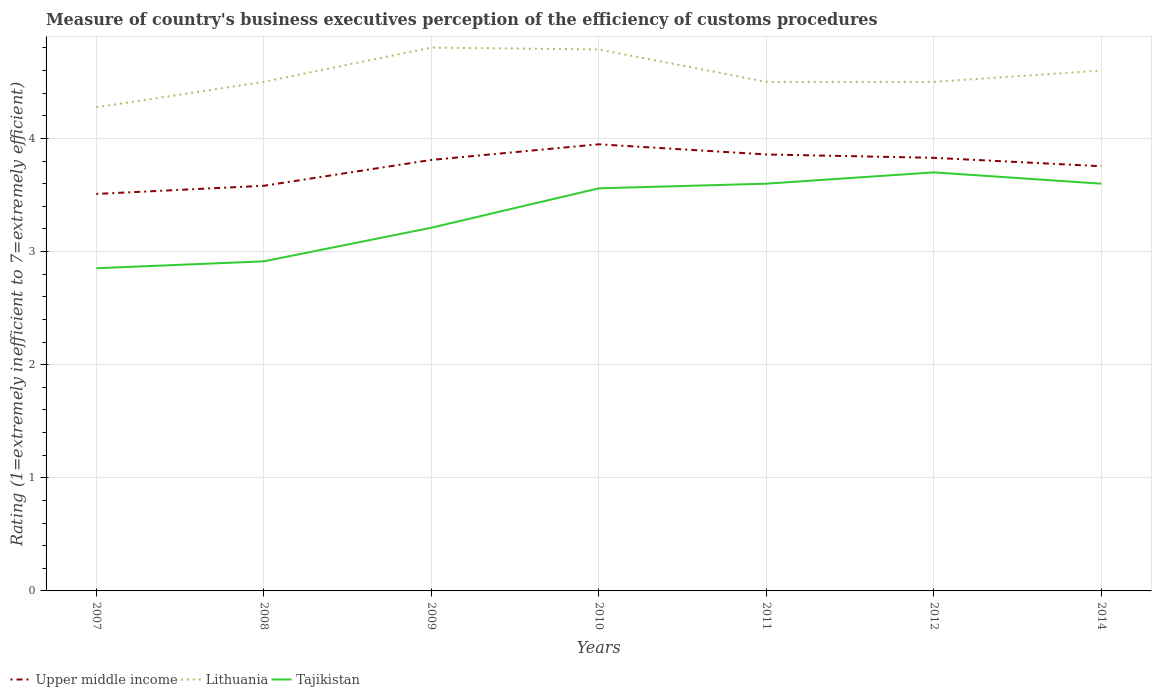How many different coloured lines are there?
Provide a succinct answer. 3. Is the number of lines equal to the number of legend labels?
Provide a succinct answer. Yes. Across all years, what is the maximum rating of the efficiency of customs procedure in Tajikistan?
Your answer should be compact. 2.85. What is the total rating of the efficiency of customs procedure in Upper middle income in the graph?
Keep it short and to the point. -0.07. What is the difference between the highest and the second highest rating of the efficiency of customs procedure in Tajikistan?
Give a very brief answer. 0.85. How many lines are there?
Ensure brevity in your answer.  3. How many years are there in the graph?
Your answer should be very brief. 7. Are the values on the major ticks of Y-axis written in scientific E-notation?
Keep it short and to the point. No. Does the graph contain any zero values?
Make the answer very short. No. Does the graph contain grids?
Ensure brevity in your answer.  Yes. Where does the legend appear in the graph?
Provide a short and direct response. Bottom left. What is the title of the graph?
Your answer should be very brief. Measure of country's business executives perception of the efficiency of customs procedures. Does "Panama" appear as one of the legend labels in the graph?
Offer a very short reply. No. What is the label or title of the Y-axis?
Offer a terse response. Rating (1=extremely inefficient to 7=extremely efficient). What is the Rating (1=extremely inefficient to 7=extremely efficient) of Upper middle income in 2007?
Ensure brevity in your answer.  3.51. What is the Rating (1=extremely inefficient to 7=extremely efficient) of Lithuania in 2007?
Offer a very short reply. 4.28. What is the Rating (1=extremely inefficient to 7=extremely efficient) of Tajikistan in 2007?
Keep it short and to the point. 2.85. What is the Rating (1=extremely inefficient to 7=extremely efficient) of Upper middle income in 2008?
Your response must be concise. 3.58. What is the Rating (1=extremely inefficient to 7=extremely efficient) of Lithuania in 2008?
Provide a succinct answer. 4.5. What is the Rating (1=extremely inefficient to 7=extremely efficient) of Tajikistan in 2008?
Provide a succinct answer. 2.91. What is the Rating (1=extremely inefficient to 7=extremely efficient) in Upper middle income in 2009?
Give a very brief answer. 3.81. What is the Rating (1=extremely inefficient to 7=extremely efficient) of Lithuania in 2009?
Keep it short and to the point. 4.8. What is the Rating (1=extremely inefficient to 7=extremely efficient) in Tajikistan in 2009?
Ensure brevity in your answer.  3.21. What is the Rating (1=extremely inefficient to 7=extremely efficient) in Upper middle income in 2010?
Provide a short and direct response. 3.95. What is the Rating (1=extremely inefficient to 7=extremely efficient) in Lithuania in 2010?
Offer a terse response. 4.79. What is the Rating (1=extremely inefficient to 7=extremely efficient) of Tajikistan in 2010?
Your answer should be compact. 3.56. What is the Rating (1=extremely inefficient to 7=extremely efficient) in Upper middle income in 2011?
Your answer should be compact. 3.86. What is the Rating (1=extremely inefficient to 7=extremely efficient) of Tajikistan in 2011?
Provide a short and direct response. 3.6. What is the Rating (1=extremely inefficient to 7=extremely efficient) of Upper middle income in 2012?
Provide a succinct answer. 3.83. What is the Rating (1=extremely inefficient to 7=extremely efficient) in Lithuania in 2012?
Offer a terse response. 4.5. What is the Rating (1=extremely inefficient to 7=extremely efficient) of Tajikistan in 2012?
Offer a terse response. 3.7. What is the Rating (1=extremely inefficient to 7=extremely efficient) in Upper middle income in 2014?
Provide a short and direct response. 3.75. What is the Rating (1=extremely inefficient to 7=extremely efficient) of Tajikistan in 2014?
Offer a terse response. 3.6. Across all years, what is the maximum Rating (1=extremely inefficient to 7=extremely efficient) of Upper middle income?
Your answer should be very brief. 3.95. Across all years, what is the maximum Rating (1=extremely inefficient to 7=extremely efficient) in Lithuania?
Give a very brief answer. 4.8. Across all years, what is the minimum Rating (1=extremely inefficient to 7=extremely efficient) in Upper middle income?
Keep it short and to the point. 3.51. Across all years, what is the minimum Rating (1=extremely inefficient to 7=extremely efficient) in Lithuania?
Your response must be concise. 4.28. Across all years, what is the minimum Rating (1=extremely inefficient to 7=extremely efficient) in Tajikistan?
Offer a terse response. 2.85. What is the total Rating (1=extremely inefficient to 7=extremely efficient) of Upper middle income in the graph?
Ensure brevity in your answer.  26.29. What is the total Rating (1=extremely inefficient to 7=extremely efficient) in Lithuania in the graph?
Give a very brief answer. 31.96. What is the total Rating (1=extremely inefficient to 7=extremely efficient) of Tajikistan in the graph?
Keep it short and to the point. 23.44. What is the difference between the Rating (1=extremely inefficient to 7=extremely efficient) of Upper middle income in 2007 and that in 2008?
Your response must be concise. -0.07. What is the difference between the Rating (1=extremely inefficient to 7=extremely efficient) of Lithuania in 2007 and that in 2008?
Ensure brevity in your answer.  -0.23. What is the difference between the Rating (1=extremely inefficient to 7=extremely efficient) in Tajikistan in 2007 and that in 2008?
Ensure brevity in your answer.  -0.06. What is the difference between the Rating (1=extremely inefficient to 7=extremely efficient) of Upper middle income in 2007 and that in 2009?
Offer a terse response. -0.3. What is the difference between the Rating (1=extremely inefficient to 7=extremely efficient) in Lithuania in 2007 and that in 2009?
Your answer should be very brief. -0.53. What is the difference between the Rating (1=extremely inefficient to 7=extremely efficient) in Tajikistan in 2007 and that in 2009?
Give a very brief answer. -0.36. What is the difference between the Rating (1=extremely inefficient to 7=extremely efficient) in Upper middle income in 2007 and that in 2010?
Make the answer very short. -0.44. What is the difference between the Rating (1=extremely inefficient to 7=extremely efficient) in Lithuania in 2007 and that in 2010?
Make the answer very short. -0.51. What is the difference between the Rating (1=extremely inefficient to 7=extremely efficient) of Tajikistan in 2007 and that in 2010?
Offer a terse response. -0.71. What is the difference between the Rating (1=extremely inefficient to 7=extremely efficient) in Upper middle income in 2007 and that in 2011?
Give a very brief answer. -0.35. What is the difference between the Rating (1=extremely inefficient to 7=extremely efficient) in Lithuania in 2007 and that in 2011?
Provide a succinct answer. -0.23. What is the difference between the Rating (1=extremely inefficient to 7=extremely efficient) of Tajikistan in 2007 and that in 2011?
Make the answer very short. -0.75. What is the difference between the Rating (1=extremely inefficient to 7=extremely efficient) of Upper middle income in 2007 and that in 2012?
Make the answer very short. -0.32. What is the difference between the Rating (1=extremely inefficient to 7=extremely efficient) in Lithuania in 2007 and that in 2012?
Offer a very short reply. -0.23. What is the difference between the Rating (1=extremely inefficient to 7=extremely efficient) in Tajikistan in 2007 and that in 2012?
Offer a terse response. -0.85. What is the difference between the Rating (1=extremely inefficient to 7=extremely efficient) of Upper middle income in 2007 and that in 2014?
Make the answer very short. -0.24. What is the difference between the Rating (1=extremely inefficient to 7=extremely efficient) in Lithuania in 2007 and that in 2014?
Provide a succinct answer. -0.33. What is the difference between the Rating (1=extremely inefficient to 7=extremely efficient) of Tajikistan in 2007 and that in 2014?
Your answer should be compact. -0.75. What is the difference between the Rating (1=extremely inefficient to 7=extremely efficient) in Upper middle income in 2008 and that in 2009?
Provide a succinct answer. -0.23. What is the difference between the Rating (1=extremely inefficient to 7=extremely efficient) of Lithuania in 2008 and that in 2009?
Give a very brief answer. -0.3. What is the difference between the Rating (1=extremely inefficient to 7=extremely efficient) of Tajikistan in 2008 and that in 2009?
Your response must be concise. -0.3. What is the difference between the Rating (1=extremely inefficient to 7=extremely efficient) of Upper middle income in 2008 and that in 2010?
Your answer should be very brief. -0.37. What is the difference between the Rating (1=extremely inefficient to 7=extremely efficient) of Lithuania in 2008 and that in 2010?
Offer a very short reply. -0.29. What is the difference between the Rating (1=extremely inefficient to 7=extremely efficient) of Tajikistan in 2008 and that in 2010?
Provide a succinct answer. -0.65. What is the difference between the Rating (1=extremely inefficient to 7=extremely efficient) of Upper middle income in 2008 and that in 2011?
Provide a short and direct response. -0.28. What is the difference between the Rating (1=extremely inefficient to 7=extremely efficient) in Tajikistan in 2008 and that in 2011?
Make the answer very short. -0.69. What is the difference between the Rating (1=extremely inefficient to 7=extremely efficient) of Upper middle income in 2008 and that in 2012?
Your answer should be very brief. -0.25. What is the difference between the Rating (1=extremely inefficient to 7=extremely efficient) in Tajikistan in 2008 and that in 2012?
Your answer should be very brief. -0.79. What is the difference between the Rating (1=extremely inefficient to 7=extremely efficient) of Upper middle income in 2008 and that in 2014?
Provide a succinct answer. -0.17. What is the difference between the Rating (1=extremely inefficient to 7=extremely efficient) of Lithuania in 2008 and that in 2014?
Provide a short and direct response. -0.1. What is the difference between the Rating (1=extremely inefficient to 7=extremely efficient) in Tajikistan in 2008 and that in 2014?
Offer a very short reply. -0.69. What is the difference between the Rating (1=extremely inefficient to 7=extremely efficient) in Upper middle income in 2009 and that in 2010?
Your response must be concise. -0.14. What is the difference between the Rating (1=extremely inefficient to 7=extremely efficient) in Lithuania in 2009 and that in 2010?
Your answer should be compact. 0.02. What is the difference between the Rating (1=extremely inefficient to 7=extremely efficient) of Tajikistan in 2009 and that in 2010?
Your response must be concise. -0.35. What is the difference between the Rating (1=extremely inefficient to 7=extremely efficient) of Upper middle income in 2009 and that in 2011?
Ensure brevity in your answer.  -0.05. What is the difference between the Rating (1=extremely inefficient to 7=extremely efficient) in Lithuania in 2009 and that in 2011?
Offer a terse response. 0.3. What is the difference between the Rating (1=extremely inefficient to 7=extremely efficient) of Tajikistan in 2009 and that in 2011?
Ensure brevity in your answer.  -0.39. What is the difference between the Rating (1=extremely inefficient to 7=extremely efficient) of Upper middle income in 2009 and that in 2012?
Make the answer very short. -0.02. What is the difference between the Rating (1=extremely inefficient to 7=extremely efficient) in Lithuania in 2009 and that in 2012?
Offer a very short reply. 0.3. What is the difference between the Rating (1=extremely inefficient to 7=extremely efficient) of Tajikistan in 2009 and that in 2012?
Provide a short and direct response. -0.49. What is the difference between the Rating (1=extremely inefficient to 7=extremely efficient) in Upper middle income in 2009 and that in 2014?
Offer a very short reply. 0.06. What is the difference between the Rating (1=extremely inefficient to 7=extremely efficient) of Lithuania in 2009 and that in 2014?
Keep it short and to the point. 0.2. What is the difference between the Rating (1=extremely inefficient to 7=extremely efficient) of Tajikistan in 2009 and that in 2014?
Keep it short and to the point. -0.39. What is the difference between the Rating (1=extremely inefficient to 7=extremely efficient) in Upper middle income in 2010 and that in 2011?
Provide a short and direct response. 0.09. What is the difference between the Rating (1=extremely inefficient to 7=extremely efficient) of Lithuania in 2010 and that in 2011?
Provide a succinct answer. 0.29. What is the difference between the Rating (1=extremely inefficient to 7=extremely efficient) in Tajikistan in 2010 and that in 2011?
Offer a terse response. -0.04. What is the difference between the Rating (1=extremely inefficient to 7=extremely efficient) of Upper middle income in 2010 and that in 2012?
Provide a short and direct response. 0.12. What is the difference between the Rating (1=extremely inefficient to 7=extremely efficient) of Lithuania in 2010 and that in 2012?
Your answer should be very brief. 0.29. What is the difference between the Rating (1=extremely inefficient to 7=extremely efficient) in Tajikistan in 2010 and that in 2012?
Your answer should be compact. -0.14. What is the difference between the Rating (1=extremely inefficient to 7=extremely efficient) of Upper middle income in 2010 and that in 2014?
Your response must be concise. 0.19. What is the difference between the Rating (1=extremely inefficient to 7=extremely efficient) in Lithuania in 2010 and that in 2014?
Keep it short and to the point. 0.19. What is the difference between the Rating (1=extremely inefficient to 7=extremely efficient) in Tajikistan in 2010 and that in 2014?
Keep it short and to the point. -0.04. What is the difference between the Rating (1=extremely inefficient to 7=extremely efficient) of Upper middle income in 2011 and that in 2012?
Offer a terse response. 0.03. What is the difference between the Rating (1=extremely inefficient to 7=extremely efficient) in Lithuania in 2011 and that in 2012?
Your answer should be very brief. 0. What is the difference between the Rating (1=extremely inefficient to 7=extremely efficient) in Upper middle income in 2011 and that in 2014?
Keep it short and to the point. 0.1. What is the difference between the Rating (1=extremely inefficient to 7=extremely efficient) of Tajikistan in 2011 and that in 2014?
Ensure brevity in your answer.  0. What is the difference between the Rating (1=extremely inefficient to 7=extremely efficient) of Upper middle income in 2012 and that in 2014?
Your answer should be very brief. 0.07. What is the difference between the Rating (1=extremely inefficient to 7=extremely efficient) in Tajikistan in 2012 and that in 2014?
Keep it short and to the point. 0.1. What is the difference between the Rating (1=extremely inefficient to 7=extremely efficient) in Upper middle income in 2007 and the Rating (1=extremely inefficient to 7=extremely efficient) in Lithuania in 2008?
Ensure brevity in your answer.  -0.99. What is the difference between the Rating (1=extremely inefficient to 7=extremely efficient) in Upper middle income in 2007 and the Rating (1=extremely inefficient to 7=extremely efficient) in Tajikistan in 2008?
Keep it short and to the point. 0.6. What is the difference between the Rating (1=extremely inefficient to 7=extremely efficient) of Lithuania in 2007 and the Rating (1=extremely inefficient to 7=extremely efficient) of Tajikistan in 2008?
Ensure brevity in your answer.  1.36. What is the difference between the Rating (1=extremely inefficient to 7=extremely efficient) of Upper middle income in 2007 and the Rating (1=extremely inefficient to 7=extremely efficient) of Lithuania in 2009?
Your answer should be compact. -1.29. What is the difference between the Rating (1=extremely inefficient to 7=extremely efficient) in Upper middle income in 2007 and the Rating (1=extremely inefficient to 7=extremely efficient) in Tajikistan in 2009?
Ensure brevity in your answer.  0.3. What is the difference between the Rating (1=extremely inefficient to 7=extremely efficient) in Lithuania in 2007 and the Rating (1=extremely inefficient to 7=extremely efficient) in Tajikistan in 2009?
Your answer should be compact. 1.06. What is the difference between the Rating (1=extremely inefficient to 7=extremely efficient) in Upper middle income in 2007 and the Rating (1=extremely inefficient to 7=extremely efficient) in Lithuania in 2010?
Provide a short and direct response. -1.28. What is the difference between the Rating (1=extremely inefficient to 7=extremely efficient) of Upper middle income in 2007 and the Rating (1=extremely inefficient to 7=extremely efficient) of Tajikistan in 2010?
Ensure brevity in your answer.  -0.05. What is the difference between the Rating (1=extremely inefficient to 7=extremely efficient) of Lithuania in 2007 and the Rating (1=extremely inefficient to 7=extremely efficient) of Tajikistan in 2010?
Keep it short and to the point. 0.72. What is the difference between the Rating (1=extremely inefficient to 7=extremely efficient) in Upper middle income in 2007 and the Rating (1=extremely inefficient to 7=extremely efficient) in Lithuania in 2011?
Provide a succinct answer. -0.99. What is the difference between the Rating (1=extremely inefficient to 7=extremely efficient) of Upper middle income in 2007 and the Rating (1=extremely inefficient to 7=extremely efficient) of Tajikistan in 2011?
Provide a short and direct response. -0.09. What is the difference between the Rating (1=extremely inefficient to 7=extremely efficient) of Lithuania in 2007 and the Rating (1=extremely inefficient to 7=extremely efficient) of Tajikistan in 2011?
Give a very brief answer. 0.68. What is the difference between the Rating (1=extremely inefficient to 7=extremely efficient) of Upper middle income in 2007 and the Rating (1=extremely inefficient to 7=extremely efficient) of Lithuania in 2012?
Your response must be concise. -0.99. What is the difference between the Rating (1=extremely inefficient to 7=extremely efficient) of Upper middle income in 2007 and the Rating (1=extremely inefficient to 7=extremely efficient) of Tajikistan in 2012?
Give a very brief answer. -0.19. What is the difference between the Rating (1=extremely inefficient to 7=extremely efficient) in Lithuania in 2007 and the Rating (1=extremely inefficient to 7=extremely efficient) in Tajikistan in 2012?
Your response must be concise. 0.57. What is the difference between the Rating (1=extremely inefficient to 7=extremely efficient) in Upper middle income in 2007 and the Rating (1=extremely inefficient to 7=extremely efficient) in Lithuania in 2014?
Your response must be concise. -1.09. What is the difference between the Rating (1=extremely inefficient to 7=extremely efficient) in Upper middle income in 2007 and the Rating (1=extremely inefficient to 7=extremely efficient) in Tajikistan in 2014?
Make the answer very short. -0.09. What is the difference between the Rating (1=extremely inefficient to 7=extremely efficient) of Lithuania in 2007 and the Rating (1=extremely inefficient to 7=extremely efficient) of Tajikistan in 2014?
Your answer should be compact. 0.68. What is the difference between the Rating (1=extremely inefficient to 7=extremely efficient) in Upper middle income in 2008 and the Rating (1=extremely inefficient to 7=extremely efficient) in Lithuania in 2009?
Offer a terse response. -1.22. What is the difference between the Rating (1=extremely inefficient to 7=extremely efficient) of Upper middle income in 2008 and the Rating (1=extremely inefficient to 7=extremely efficient) of Tajikistan in 2009?
Your answer should be very brief. 0.37. What is the difference between the Rating (1=extremely inefficient to 7=extremely efficient) of Lithuania in 2008 and the Rating (1=extremely inefficient to 7=extremely efficient) of Tajikistan in 2009?
Your response must be concise. 1.29. What is the difference between the Rating (1=extremely inefficient to 7=extremely efficient) of Upper middle income in 2008 and the Rating (1=extremely inefficient to 7=extremely efficient) of Lithuania in 2010?
Offer a terse response. -1.21. What is the difference between the Rating (1=extremely inefficient to 7=extremely efficient) of Upper middle income in 2008 and the Rating (1=extremely inefficient to 7=extremely efficient) of Tajikistan in 2010?
Your answer should be compact. 0.02. What is the difference between the Rating (1=extremely inefficient to 7=extremely efficient) of Lithuania in 2008 and the Rating (1=extremely inefficient to 7=extremely efficient) of Tajikistan in 2010?
Provide a short and direct response. 0.94. What is the difference between the Rating (1=extremely inefficient to 7=extremely efficient) in Upper middle income in 2008 and the Rating (1=extremely inefficient to 7=extremely efficient) in Lithuania in 2011?
Offer a very short reply. -0.92. What is the difference between the Rating (1=extremely inefficient to 7=extremely efficient) of Upper middle income in 2008 and the Rating (1=extremely inefficient to 7=extremely efficient) of Tajikistan in 2011?
Your answer should be very brief. -0.02. What is the difference between the Rating (1=extremely inefficient to 7=extremely efficient) of Lithuania in 2008 and the Rating (1=extremely inefficient to 7=extremely efficient) of Tajikistan in 2011?
Provide a succinct answer. 0.9. What is the difference between the Rating (1=extremely inefficient to 7=extremely efficient) of Upper middle income in 2008 and the Rating (1=extremely inefficient to 7=extremely efficient) of Lithuania in 2012?
Offer a very short reply. -0.92. What is the difference between the Rating (1=extremely inefficient to 7=extremely efficient) of Upper middle income in 2008 and the Rating (1=extremely inefficient to 7=extremely efficient) of Tajikistan in 2012?
Provide a succinct answer. -0.12. What is the difference between the Rating (1=extremely inefficient to 7=extremely efficient) in Lithuania in 2008 and the Rating (1=extremely inefficient to 7=extremely efficient) in Tajikistan in 2012?
Provide a short and direct response. 0.8. What is the difference between the Rating (1=extremely inefficient to 7=extremely efficient) in Upper middle income in 2008 and the Rating (1=extremely inefficient to 7=extremely efficient) in Lithuania in 2014?
Provide a short and direct response. -1.02. What is the difference between the Rating (1=extremely inefficient to 7=extremely efficient) of Upper middle income in 2008 and the Rating (1=extremely inefficient to 7=extremely efficient) of Tajikistan in 2014?
Offer a terse response. -0.02. What is the difference between the Rating (1=extremely inefficient to 7=extremely efficient) in Lithuania in 2008 and the Rating (1=extremely inefficient to 7=extremely efficient) in Tajikistan in 2014?
Make the answer very short. 0.9. What is the difference between the Rating (1=extremely inefficient to 7=extremely efficient) of Upper middle income in 2009 and the Rating (1=extremely inefficient to 7=extremely efficient) of Lithuania in 2010?
Give a very brief answer. -0.98. What is the difference between the Rating (1=extremely inefficient to 7=extremely efficient) of Upper middle income in 2009 and the Rating (1=extremely inefficient to 7=extremely efficient) of Tajikistan in 2010?
Give a very brief answer. 0.25. What is the difference between the Rating (1=extremely inefficient to 7=extremely efficient) in Lithuania in 2009 and the Rating (1=extremely inefficient to 7=extremely efficient) in Tajikistan in 2010?
Ensure brevity in your answer.  1.24. What is the difference between the Rating (1=extremely inefficient to 7=extremely efficient) in Upper middle income in 2009 and the Rating (1=extremely inefficient to 7=extremely efficient) in Lithuania in 2011?
Provide a succinct answer. -0.69. What is the difference between the Rating (1=extremely inefficient to 7=extremely efficient) in Upper middle income in 2009 and the Rating (1=extremely inefficient to 7=extremely efficient) in Tajikistan in 2011?
Make the answer very short. 0.21. What is the difference between the Rating (1=extremely inefficient to 7=extremely efficient) in Lithuania in 2009 and the Rating (1=extremely inefficient to 7=extremely efficient) in Tajikistan in 2011?
Your answer should be compact. 1.2. What is the difference between the Rating (1=extremely inefficient to 7=extremely efficient) of Upper middle income in 2009 and the Rating (1=extremely inefficient to 7=extremely efficient) of Lithuania in 2012?
Offer a terse response. -0.69. What is the difference between the Rating (1=extremely inefficient to 7=extremely efficient) in Upper middle income in 2009 and the Rating (1=extremely inefficient to 7=extremely efficient) in Tajikistan in 2012?
Provide a short and direct response. 0.11. What is the difference between the Rating (1=extremely inefficient to 7=extremely efficient) in Lithuania in 2009 and the Rating (1=extremely inefficient to 7=extremely efficient) in Tajikistan in 2012?
Make the answer very short. 1.1. What is the difference between the Rating (1=extremely inefficient to 7=extremely efficient) in Upper middle income in 2009 and the Rating (1=extremely inefficient to 7=extremely efficient) in Lithuania in 2014?
Ensure brevity in your answer.  -0.79. What is the difference between the Rating (1=extremely inefficient to 7=extremely efficient) of Upper middle income in 2009 and the Rating (1=extremely inefficient to 7=extremely efficient) of Tajikistan in 2014?
Ensure brevity in your answer.  0.21. What is the difference between the Rating (1=extremely inefficient to 7=extremely efficient) in Lithuania in 2009 and the Rating (1=extremely inefficient to 7=extremely efficient) in Tajikistan in 2014?
Your answer should be compact. 1.2. What is the difference between the Rating (1=extremely inefficient to 7=extremely efficient) of Upper middle income in 2010 and the Rating (1=extremely inefficient to 7=extremely efficient) of Lithuania in 2011?
Keep it short and to the point. -0.55. What is the difference between the Rating (1=extremely inefficient to 7=extremely efficient) of Upper middle income in 2010 and the Rating (1=extremely inefficient to 7=extremely efficient) of Tajikistan in 2011?
Provide a succinct answer. 0.35. What is the difference between the Rating (1=extremely inefficient to 7=extremely efficient) in Lithuania in 2010 and the Rating (1=extremely inefficient to 7=extremely efficient) in Tajikistan in 2011?
Provide a short and direct response. 1.19. What is the difference between the Rating (1=extremely inefficient to 7=extremely efficient) of Upper middle income in 2010 and the Rating (1=extremely inefficient to 7=extremely efficient) of Lithuania in 2012?
Keep it short and to the point. -0.55. What is the difference between the Rating (1=extremely inefficient to 7=extremely efficient) in Upper middle income in 2010 and the Rating (1=extremely inefficient to 7=extremely efficient) in Tajikistan in 2012?
Your answer should be compact. 0.25. What is the difference between the Rating (1=extremely inefficient to 7=extremely efficient) in Lithuania in 2010 and the Rating (1=extremely inefficient to 7=extremely efficient) in Tajikistan in 2012?
Make the answer very short. 1.09. What is the difference between the Rating (1=extremely inefficient to 7=extremely efficient) in Upper middle income in 2010 and the Rating (1=extremely inefficient to 7=extremely efficient) in Lithuania in 2014?
Keep it short and to the point. -0.65. What is the difference between the Rating (1=extremely inefficient to 7=extremely efficient) of Upper middle income in 2010 and the Rating (1=extremely inefficient to 7=extremely efficient) of Tajikistan in 2014?
Your answer should be compact. 0.35. What is the difference between the Rating (1=extremely inefficient to 7=extremely efficient) of Lithuania in 2010 and the Rating (1=extremely inefficient to 7=extremely efficient) of Tajikistan in 2014?
Provide a short and direct response. 1.19. What is the difference between the Rating (1=extremely inefficient to 7=extremely efficient) of Upper middle income in 2011 and the Rating (1=extremely inefficient to 7=extremely efficient) of Lithuania in 2012?
Ensure brevity in your answer.  -0.64. What is the difference between the Rating (1=extremely inefficient to 7=extremely efficient) of Upper middle income in 2011 and the Rating (1=extremely inefficient to 7=extremely efficient) of Tajikistan in 2012?
Your response must be concise. 0.16. What is the difference between the Rating (1=extremely inefficient to 7=extremely efficient) of Upper middle income in 2011 and the Rating (1=extremely inefficient to 7=extremely efficient) of Lithuania in 2014?
Offer a very short reply. -0.74. What is the difference between the Rating (1=extremely inefficient to 7=extremely efficient) in Upper middle income in 2011 and the Rating (1=extremely inefficient to 7=extremely efficient) in Tajikistan in 2014?
Offer a terse response. 0.26. What is the difference between the Rating (1=extremely inefficient to 7=extremely efficient) in Lithuania in 2011 and the Rating (1=extremely inefficient to 7=extremely efficient) in Tajikistan in 2014?
Ensure brevity in your answer.  0.9. What is the difference between the Rating (1=extremely inefficient to 7=extremely efficient) in Upper middle income in 2012 and the Rating (1=extremely inefficient to 7=extremely efficient) in Lithuania in 2014?
Make the answer very short. -0.77. What is the difference between the Rating (1=extremely inefficient to 7=extremely efficient) of Upper middle income in 2012 and the Rating (1=extremely inefficient to 7=extremely efficient) of Tajikistan in 2014?
Offer a very short reply. 0.23. What is the difference between the Rating (1=extremely inefficient to 7=extremely efficient) of Lithuania in 2012 and the Rating (1=extremely inefficient to 7=extremely efficient) of Tajikistan in 2014?
Give a very brief answer. 0.9. What is the average Rating (1=extremely inefficient to 7=extremely efficient) in Upper middle income per year?
Provide a short and direct response. 3.76. What is the average Rating (1=extremely inefficient to 7=extremely efficient) of Lithuania per year?
Provide a succinct answer. 4.57. What is the average Rating (1=extremely inefficient to 7=extremely efficient) of Tajikistan per year?
Provide a succinct answer. 3.35. In the year 2007, what is the difference between the Rating (1=extremely inefficient to 7=extremely efficient) of Upper middle income and Rating (1=extremely inefficient to 7=extremely efficient) of Lithuania?
Offer a very short reply. -0.77. In the year 2007, what is the difference between the Rating (1=extremely inefficient to 7=extremely efficient) in Upper middle income and Rating (1=extremely inefficient to 7=extremely efficient) in Tajikistan?
Your answer should be compact. 0.66. In the year 2007, what is the difference between the Rating (1=extremely inefficient to 7=extremely efficient) of Lithuania and Rating (1=extremely inefficient to 7=extremely efficient) of Tajikistan?
Provide a short and direct response. 1.42. In the year 2008, what is the difference between the Rating (1=extremely inefficient to 7=extremely efficient) of Upper middle income and Rating (1=extremely inefficient to 7=extremely efficient) of Lithuania?
Provide a succinct answer. -0.92. In the year 2008, what is the difference between the Rating (1=extremely inefficient to 7=extremely efficient) in Upper middle income and Rating (1=extremely inefficient to 7=extremely efficient) in Tajikistan?
Your answer should be compact. 0.67. In the year 2008, what is the difference between the Rating (1=extremely inefficient to 7=extremely efficient) in Lithuania and Rating (1=extremely inefficient to 7=extremely efficient) in Tajikistan?
Your answer should be very brief. 1.59. In the year 2009, what is the difference between the Rating (1=extremely inefficient to 7=extremely efficient) of Upper middle income and Rating (1=extremely inefficient to 7=extremely efficient) of Lithuania?
Your answer should be compact. -0.99. In the year 2009, what is the difference between the Rating (1=extremely inefficient to 7=extremely efficient) of Upper middle income and Rating (1=extremely inefficient to 7=extremely efficient) of Tajikistan?
Your answer should be very brief. 0.6. In the year 2009, what is the difference between the Rating (1=extremely inefficient to 7=extremely efficient) in Lithuania and Rating (1=extremely inefficient to 7=extremely efficient) in Tajikistan?
Your response must be concise. 1.59. In the year 2010, what is the difference between the Rating (1=extremely inefficient to 7=extremely efficient) in Upper middle income and Rating (1=extremely inefficient to 7=extremely efficient) in Lithuania?
Give a very brief answer. -0.84. In the year 2010, what is the difference between the Rating (1=extremely inefficient to 7=extremely efficient) of Upper middle income and Rating (1=extremely inefficient to 7=extremely efficient) of Tajikistan?
Your answer should be compact. 0.39. In the year 2010, what is the difference between the Rating (1=extremely inefficient to 7=extremely efficient) of Lithuania and Rating (1=extremely inefficient to 7=extremely efficient) of Tajikistan?
Offer a terse response. 1.23. In the year 2011, what is the difference between the Rating (1=extremely inefficient to 7=extremely efficient) of Upper middle income and Rating (1=extremely inefficient to 7=extremely efficient) of Lithuania?
Provide a succinct answer. -0.64. In the year 2011, what is the difference between the Rating (1=extremely inefficient to 7=extremely efficient) of Upper middle income and Rating (1=extremely inefficient to 7=extremely efficient) of Tajikistan?
Make the answer very short. 0.26. In the year 2011, what is the difference between the Rating (1=extremely inefficient to 7=extremely efficient) in Lithuania and Rating (1=extremely inefficient to 7=extremely efficient) in Tajikistan?
Your response must be concise. 0.9. In the year 2012, what is the difference between the Rating (1=extremely inefficient to 7=extremely efficient) of Upper middle income and Rating (1=extremely inefficient to 7=extremely efficient) of Lithuania?
Offer a very short reply. -0.67. In the year 2012, what is the difference between the Rating (1=extremely inefficient to 7=extremely efficient) in Upper middle income and Rating (1=extremely inefficient to 7=extremely efficient) in Tajikistan?
Provide a succinct answer. 0.13. In the year 2012, what is the difference between the Rating (1=extremely inefficient to 7=extremely efficient) of Lithuania and Rating (1=extremely inefficient to 7=extremely efficient) of Tajikistan?
Provide a short and direct response. 0.8. In the year 2014, what is the difference between the Rating (1=extremely inefficient to 7=extremely efficient) in Upper middle income and Rating (1=extremely inefficient to 7=extremely efficient) in Lithuania?
Provide a succinct answer. -0.85. In the year 2014, what is the difference between the Rating (1=extremely inefficient to 7=extremely efficient) of Upper middle income and Rating (1=extremely inefficient to 7=extremely efficient) of Tajikistan?
Your answer should be very brief. 0.15. What is the ratio of the Rating (1=extremely inefficient to 7=extremely efficient) in Upper middle income in 2007 to that in 2008?
Provide a short and direct response. 0.98. What is the ratio of the Rating (1=extremely inefficient to 7=extremely efficient) in Lithuania in 2007 to that in 2008?
Give a very brief answer. 0.95. What is the ratio of the Rating (1=extremely inefficient to 7=extremely efficient) of Tajikistan in 2007 to that in 2008?
Offer a very short reply. 0.98. What is the ratio of the Rating (1=extremely inefficient to 7=extremely efficient) in Upper middle income in 2007 to that in 2009?
Your response must be concise. 0.92. What is the ratio of the Rating (1=extremely inefficient to 7=extremely efficient) of Lithuania in 2007 to that in 2009?
Give a very brief answer. 0.89. What is the ratio of the Rating (1=extremely inefficient to 7=extremely efficient) in Tajikistan in 2007 to that in 2009?
Make the answer very short. 0.89. What is the ratio of the Rating (1=extremely inefficient to 7=extremely efficient) of Lithuania in 2007 to that in 2010?
Offer a very short reply. 0.89. What is the ratio of the Rating (1=extremely inefficient to 7=extremely efficient) in Tajikistan in 2007 to that in 2010?
Your response must be concise. 0.8. What is the ratio of the Rating (1=extremely inefficient to 7=extremely efficient) of Upper middle income in 2007 to that in 2011?
Offer a very short reply. 0.91. What is the ratio of the Rating (1=extremely inefficient to 7=extremely efficient) of Lithuania in 2007 to that in 2011?
Provide a succinct answer. 0.95. What is the ratio of the Rating (1=extremely inefficient to 7=extremely efficient) of Tajikistan in 2007 to that in 2011?
Your answer should be very brief. 0.79. What is the ratio of the Rating (1=extremely inefficient to 7=extremely efficient) of Upper middle income in 2007 to that in 2012?
Keep it short and to the point. 0.92. What is the ratio of the Rating (1=extremely inefficient to 7=extremely efficient) of Tajikistan in 2007 to that in 2012?
Ensure brevity in your answer.  0.77. What is the ratio of the Rating (1=extremely inefficient to 7=extremely efficient) in Upper middle income in 2007 to that in 2014?
Provide a short and direct response. 0.93. What is the ratio of the Rating (1=extremely inefficient to 7=extremely efficient) of Lithuania in 2007 to that in 2014?
Your response must be concise. 0.93. What is the ratio of the Rating (1=extremely inefficient to 7=extremely efficient) in Tajikistan in 2007 to that in 2014?
Give a very brief answer. 0.79. What is the ratio of the Rating (1=extremely inefficient to 7=extremely efficient) of Upper middle income in 2008 to that in 2009?
Provide a short and direct response. 0.94. What is the ratio of the Rating (1=extremely inefficient to 7=extremely efficient) of Lithuania in 2008 to that in 2009?
Ensure brevity in your answer.  0.94. What is the ratio of the Rating (1=extremely inefficient to 7=extremely efficient) in Tajikistan in 2008 to that in 2009?
Provide a succinct answer. 0.91. What is the ratio of the Rating (1=extremely inefficient to 7=extremely efficient) of Upper middle income in 2008 to that in 2010?
Ensure brevity in your answer.  0.91. What is the ratio of the Rating (1=extremely inefficient to 7=extremely efficient) in Lithuania in 2008 to that in 2010?
Your answer should be very brief. 0.94. What is the ratio of the Rating (1=extremely inefficient to 7=extremely efficient) in Tajikistan in 2008 to that in 2010?
Offer a terse response. 0.82. What is the ratio of the Rating (1=extremely inefficient to 7=extremely efficient) in Upper middle income in 2008 to that in 2011?
Give a very brief answer. 0.93. What is the ratio of the Rating (1=extremely inefficient to 7=extremely efficient) of Lithuania in 2008 to that in 2011?
Your response must be concise. 1. What is the ratio of the Rating (1=extremely inefficient to 7=extremely efficient) in Tajikistan in 2008 to that in 2011?
Make the answer very short. 0.81. What is the ratio of the Rating (1=extremely inefficient to 7=extremely efficient) in Upper middle income in 2008 to that in 2012?
Provide a short and direct response. 0.94. What is the ratio of the Rating (1=extremely inefficient to 7=extremely efficient) in Lithuania in 2008 to that in 2012?
Keep it short and to the point. 1. What is the ratio of the Rating (1=extremely inefficient to 7=extremely efficient) of Tajikistan in 2008 to that in 2012?
Your response must be concise. 0.79. What is the ratio of the Rating (1=extremely inefficient to 7=extremely efficient) in Upper middle income in 2008 to that in 2014?
Keep it short and to the point. 0.95. What is the ratio of the Rating (1=extremely inefficient to 7=extremely efficient) of Lithuania in 2008 to that in 2014?
Your answer should be very brief. 0.98. What is the ratio of the Rating (1=extremely inefficient to 7=extremely efficient) of Tajikistan in 2008 to that in 2014?
Your response must be concise. 0.81. What is the ratio of the Rating (1=extremely inefficient to 7=extremely efficient) of Tajikistan in 2009 to that in 2010?
Your response must be concise. 0.9. What is the ratio of the Rating (1=extremely inefficient to 7=extremely efficient) of Upper middle income in 2009 to that in 2011?
Offer a very short reply. 0.99. What is the ratio of the Rating (1=extremely inefficient to 7=extremely efficient) of Lithuania in 2009 to that in 2011?
Provide a succinct answer. 1.07. What is the ratio of the Rating (1=extremely inefficient to 7=extremely efficient) in Tajikistan in 2009 to that in 2011?
Provide a succinct answer. 0.89. What is the ratio of the Rating (1=extremely inefficient to 7=extremely efficient) in Lithuania in 2009 to that in 2012?
Offer a terse response. 1.07. What is the ratio of the Rating (1=extremely inefficient to 7=extremely efficient) in Tajikistan in 2009 to that in 2012?
Provide a succinct answer. 0.87. What is the ratio of the Rating (1=extremely inefficient to 7=extremely efficient) of Upper middle income in 2009 to that in 2014?
Your response must be concise. 1.01. What is the ratio of the Rating (1=extremely inefficient to 7=extremely efficient) of Lithuania in 2009 to that in 2014?
Make the answer very short. 1.04. What is the ratio of the Rating (1=extremely inefficient to 7=extremely efficient) in Tajikistan in 2009 to that in 2014?
Your response must be concise. 0.89. What is the ratio of the Rating (1=extremely inefficient to 7=extremely efficient) in Upper middle income in 2010 to that in 2011?
Your response must be concise. 1.02. What is the ratio of the Rating (1=extremely inefficient to 7=extremely efficient) in Lithuania in 2010 to that in 2011?
Ensure brevity in your answer.  1.06. What is the ratio of the Rating (1=extremely inefficient to 7=extremely efficient) in Tajikistan in 2010 to that in 2011?
Keep it short and to the point. 0.99. What is the ratio of the Rating (1=extremely inefficient to 7=extremely efficient) of Upper middle income in 2010 to that in 2012?
Your answer should be compact. 1.03. What is the ratio of the Rating (1=extremely inefficient to 7=extremely efficient) in Lithuania in 2010 to that in 2012?
Provide a short and direct response. 1.06. What is the ratio of the Rating (1=extremely inefficient to 7=extremely efficient) in Tajikistan in 2010 to that in 2012?
Give a very brief answer. 0.96. What is the ratio of the Rating (1=extremely inefficient to 7=extremely efficient) in Upper middle income in 2010 to that in 2014?
Your answer should be very brief. 1.05. What is the ratio of the Rating (1=extremely inefficient to 7=extremely efficient) of Lithuania in 2010 to that in 2014?
Your response must be concise. 1.04. What is the ratio of the Rating (1=extremely inefficient to 7=extremely efficient) of Lithuania in 2011 to that in 2012?
Offer a terse response. 1. What is the ratio of the Rating (1=extremely inefficient to 7=extremely efficient) in Tajikistan in 2011 to that in 2012?
Make the answer very short. 0.97. What is the ratio of the Rating (1=extremely inefficient to 7=extremely efficient) in Upper middle income in 2011 to that in 2014?
Provide a short and direct response. 1.03. What is the ratio of the Rating (1=extremely inefficient to 7=extremely efficient) of Lithuania in 2011 to that in 2014?
Keep it short and to the point. 0.98. What is the ratio of the Rating (1=extremely inefficient to 7=extremely efficient) in Tajikistan in 2011 to that in 2014?
Your answer should be very brief. 1. What is the ratio of the Rating (1=extremely inefficient to 7=extremely efficient) in Upper middle income in 2012 to that in 2014?
Offer a very short reply. 1.02. What is the ratio of the Rating (1=extremely inefficient to 7=extremely efficient) in Lithuania in 2012 to that in 2014?
Keep it short and to the point. 0.98. What is the ratio of the Rating (1=extremely inefficient to 7=extremely efficient) of Tajikistan in 2012 to that in 2014?
Your answer should be very brief. 1.03. What is the difference between the highest and the second highest Rating (1=extremely inefficient to 7=extremely efficient) of Upper middle income?
Provide a succinct answer. 0.09. What is the difference between the highest and the second highest Rating (1=extremely inefficient to 7=extremely efficient) in Lithuania?
Your response must be concise. 0.02. What is the difference between the highest and the lowest Rating (1=extremely inefficient to 7=extremely efficient) of Upper middle income?
Provide a short and direct response. 0.44. What is the difference between the highest and the lowest Rating (1=extremely inefficient to 7=extremely efficient) in Lithuania?
Your answer should be very brief. 0.53. What is the difference between the highest and the lowest Rating (1=extremely inefficient to 7=extremely efficient) of Tajikistan?
Provide a succinct answer. 0.85. 